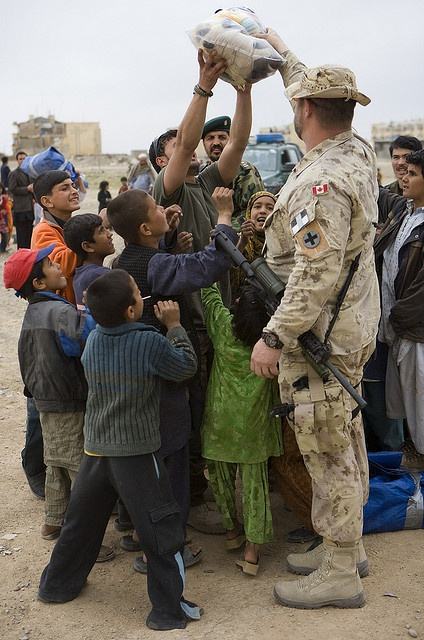Describe the objects in this image and their specific colors. I can see people in lightgray, gray, and darkgray tones, people in lightgray, black, gray, and darkblue tones, people in lightgray, black, darkgreen, and olive tones, people in lightgray, black, gray, and maroon tones, and people in lightgray, black, maroon, and gray tones in this image. 